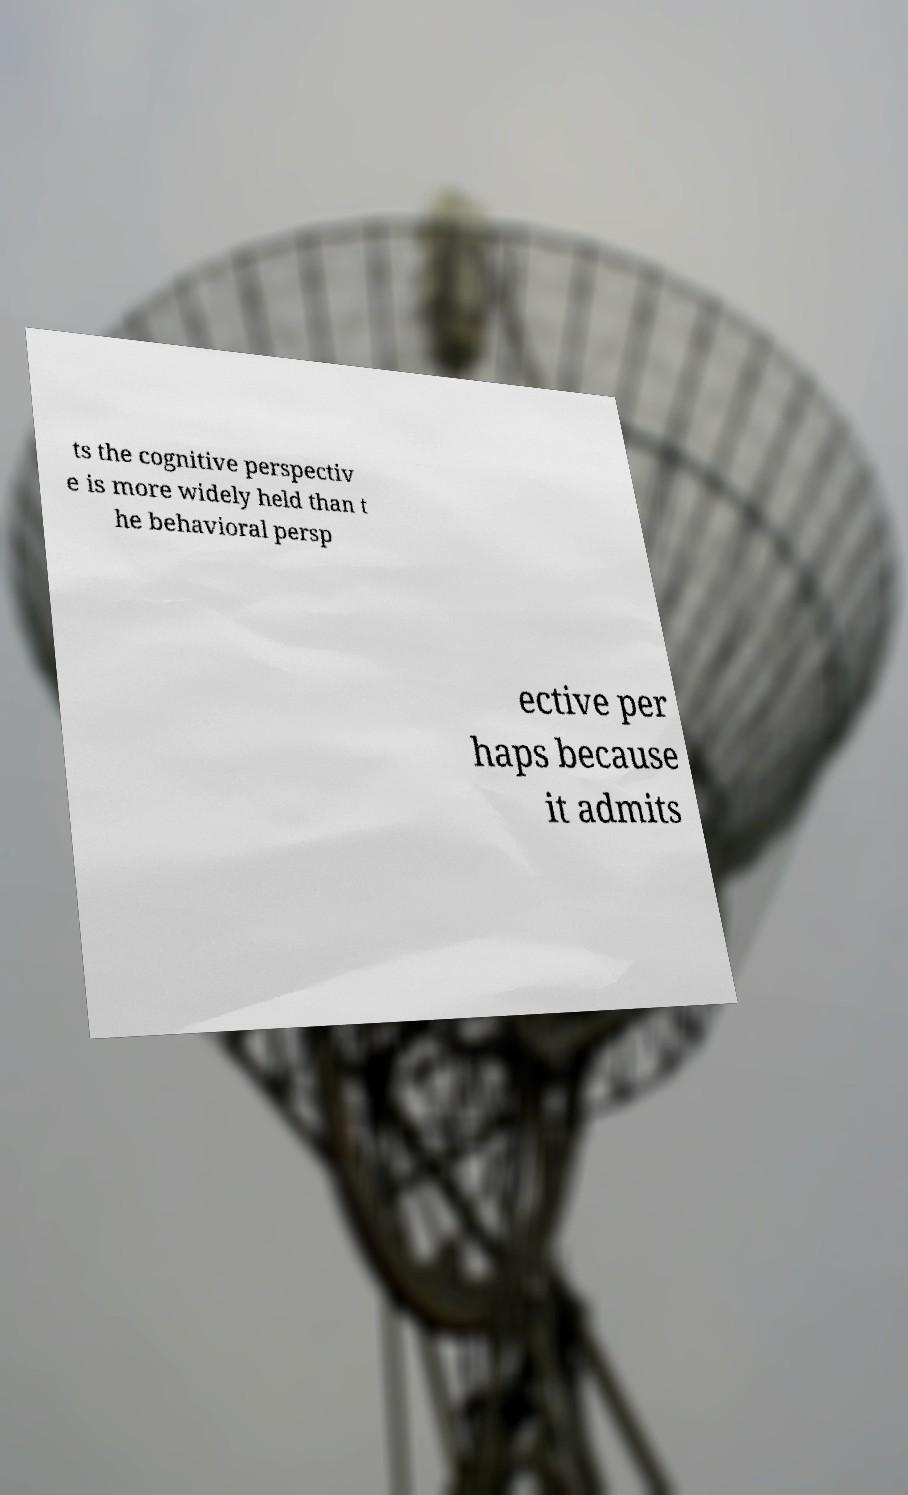Can you accurately transcribe the text from the provided image for me? ts the cognitive perspectiv e is more widely held than t he behavioral persp ective per haps because it admits 